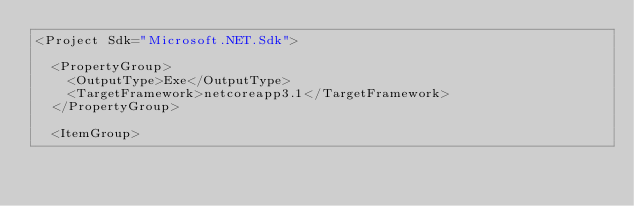<code> <loc_0><loc_0><loc_500><loc_500><_XML_><Project Sdk="Microsoft.NET.Sdk">

  <PropertyGroup>
    <OutputType>Exe</OutputType>
    <TargetFramework>netcoreapp3.1</TargetFramework>
  </PropertyGroup>

  <ItemGroup></code> 